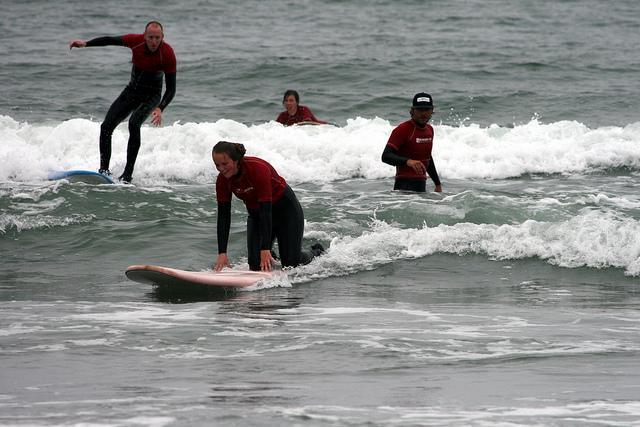What does the girl walking into the water is waiting for what to come from directly behind her so she can stand up on the board from the water waiting for what the only thing that will get her on moving on the board?

Choices:
A) wave
B) sun
C) her hands
D) sand wave 